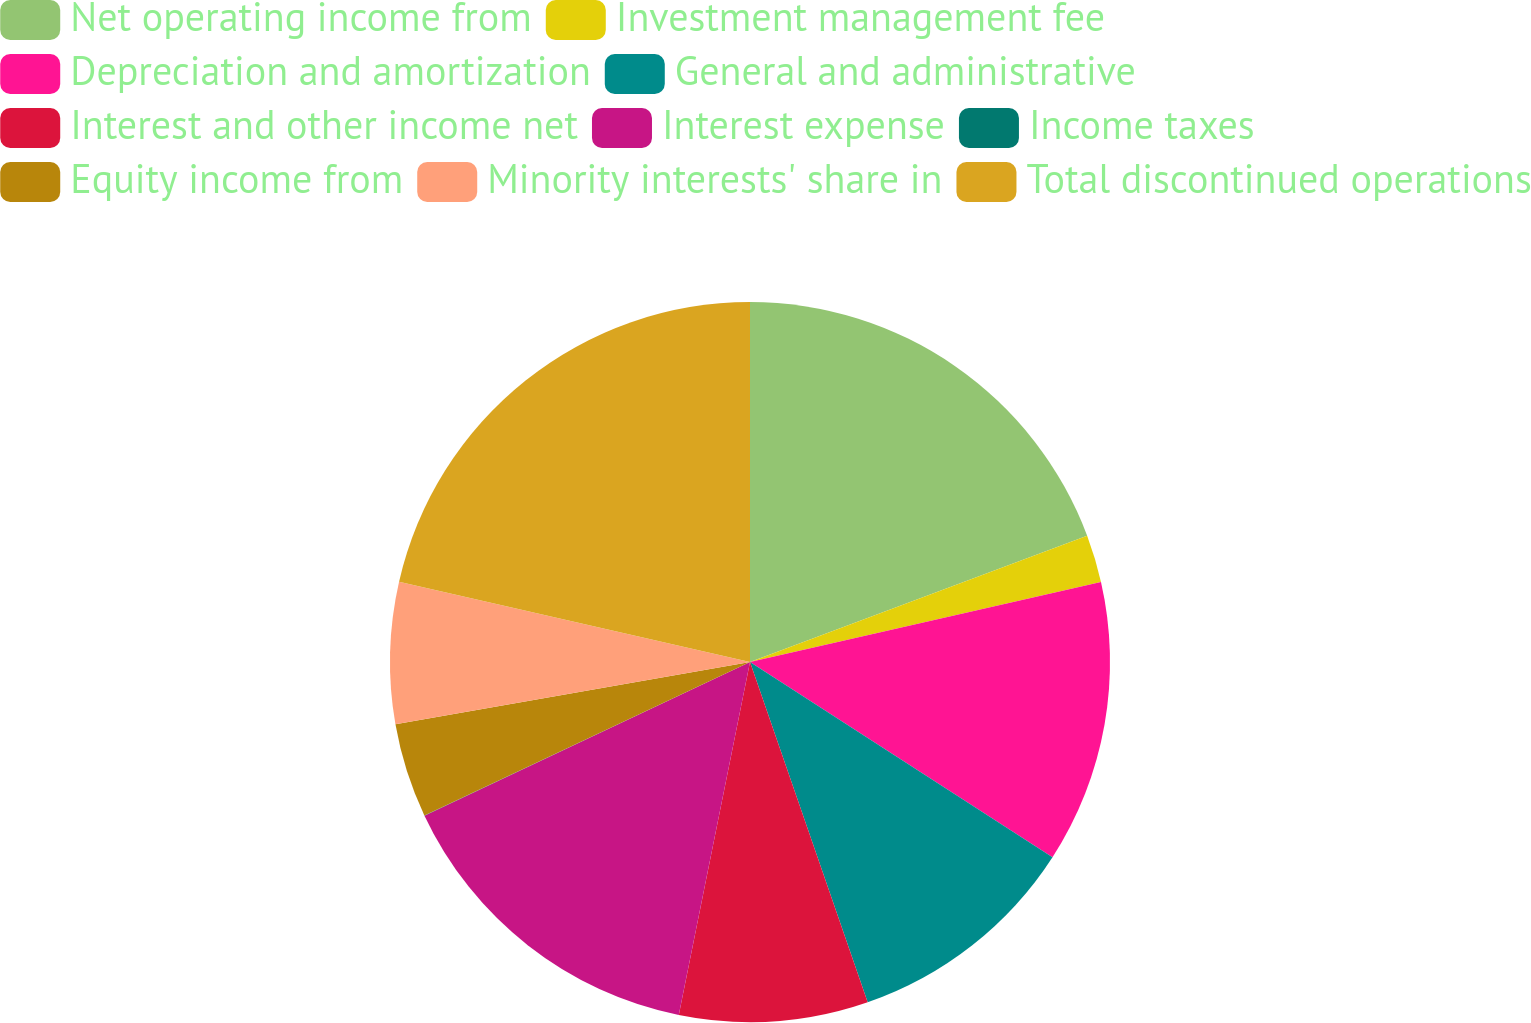Convert chart to OTSL. <chart><loc_0><loc_0><loc_500><loc_500><pie_chart><fcel>Net operating income from<fcel>Investment management fee<fcel>Depreciation and amortization<fcel>General and administrative<fcel>Interest and other income net<fcel>Interest expense<fcel>Income taxes<fcel>Equity income from<fcel>Minority interests' share in<fcel>Total discontinued operations<nl><fcel>19.3%<fcel>2.13%<fcel>12.69%<fcel>10.58%<fcel>8.47%<fcel>14.81%<fcel>0.01%<fcel>4.24%<fcel>6.35%<fcel>21.42%<nl></chart> 